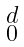Convert formula to latex. <formula><loc_0><loc_0><loc_500><loc_500>\begin{smallmatrix} d \\ 0 \end{smallmatrix}</formula> 